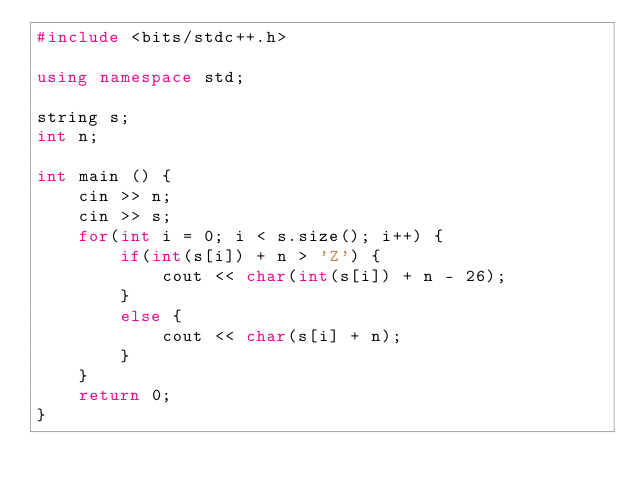<code> <loc_0><loc_0><loc_500><loc_500><_C++_>#include <bits/stdc++.h>

using namespace std;

string s;
int n;

int main () {
	cin >> n;
	cin >> s;
	for(int i = 0; i < s.size(); i++) {
		if(int(s[i]) + n > 'Z') {
			cout << char(int(s[i]) + n - 26);
		}
		else {
			cout << char(s[i] + n);
		}
	}
	return 0;
}</code> 